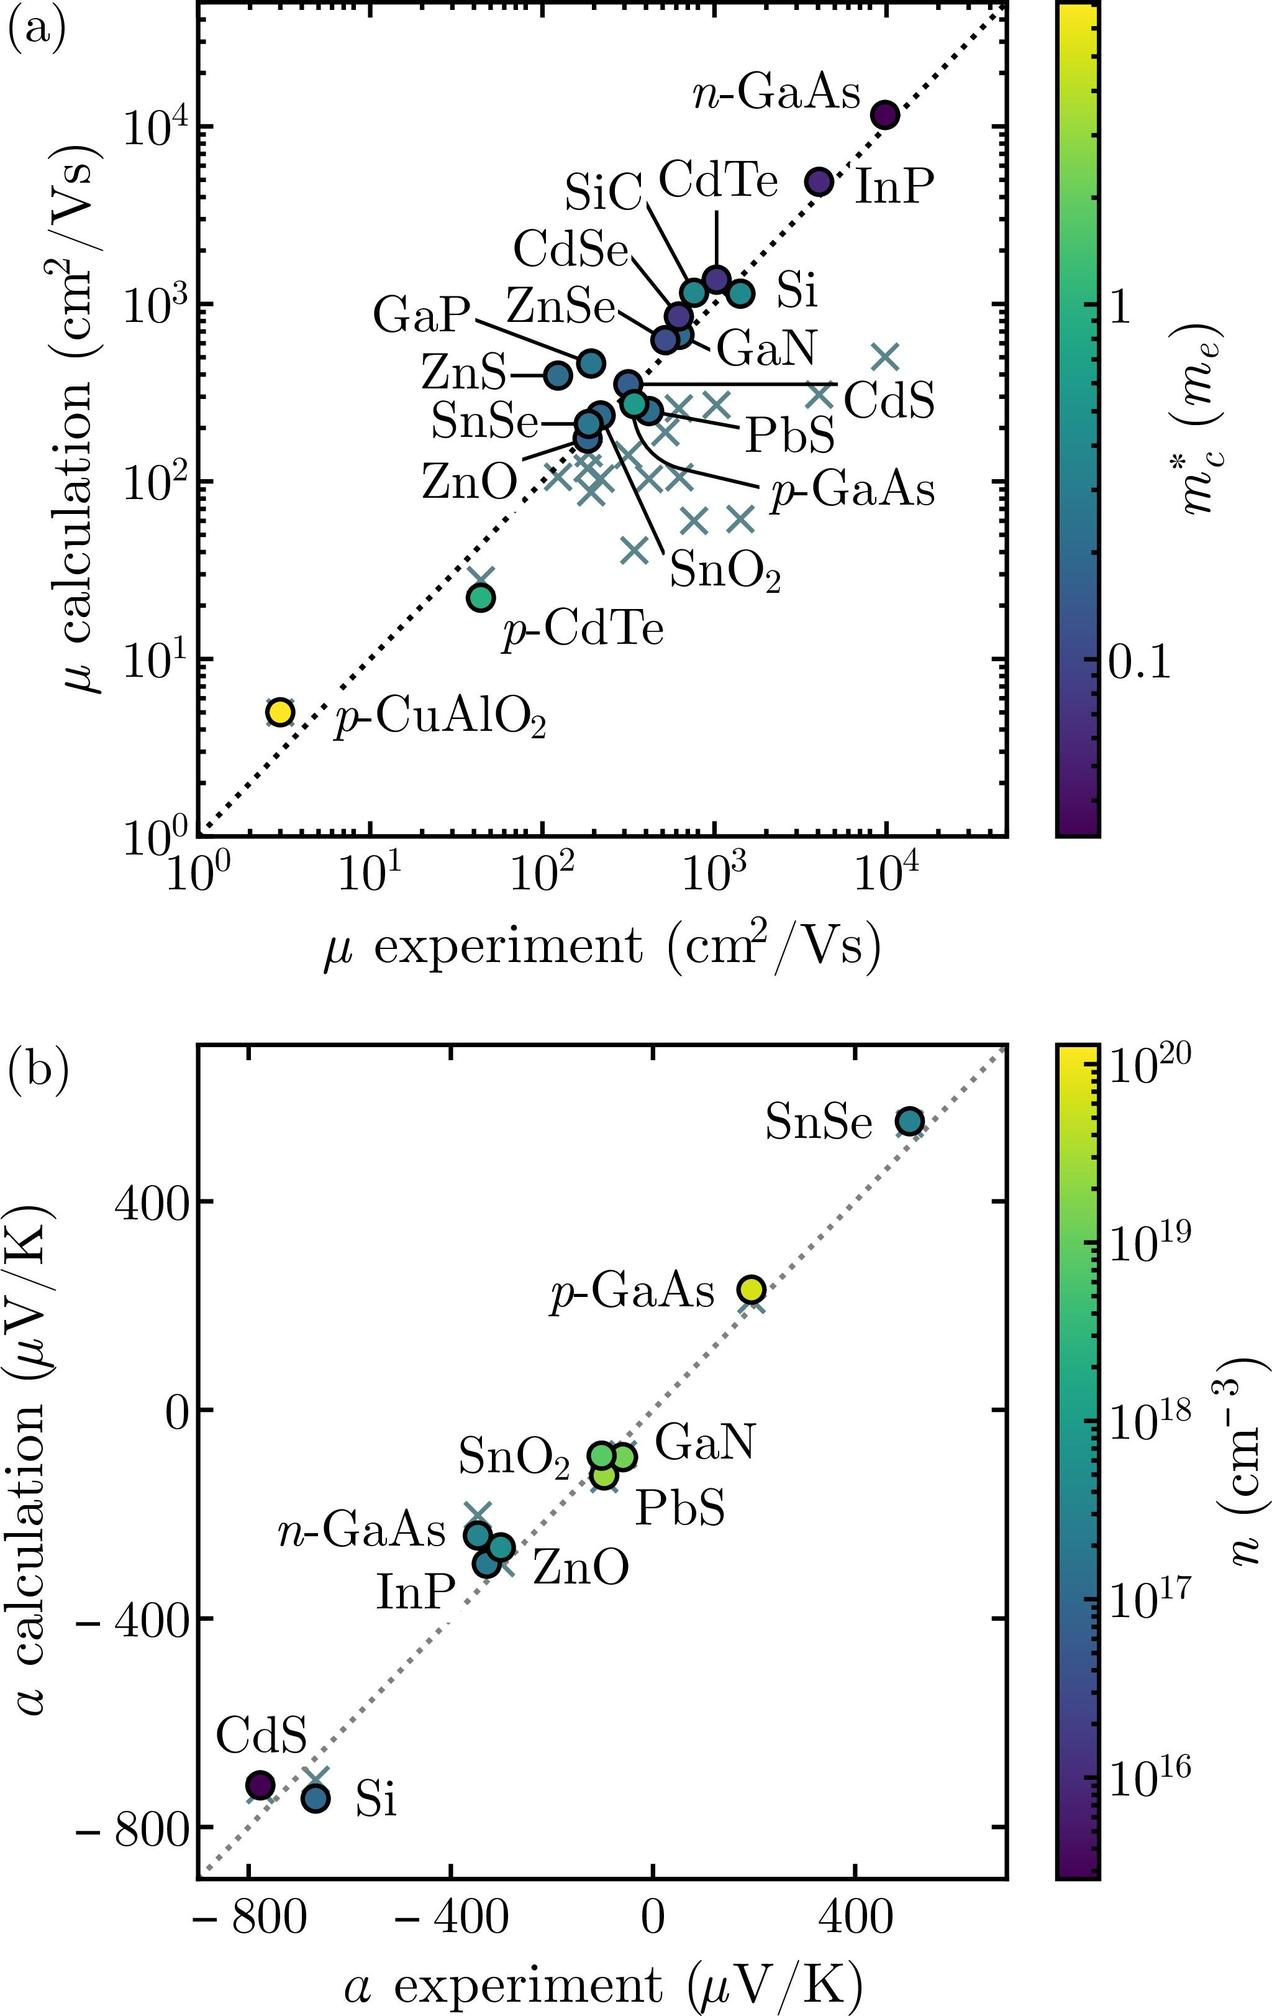Can you explain the significance of the color gradient in the plot? Certainly! The color gradient in the plot represents the carrier concentration (typically denoted by \( n \)) of the various semiconductor materials. This value is expressed in units of \( cm^{-3} \) and spans several orders of magnitude. The gradient ranges from purple, denoting a lower carrier concentration (\( 10^{16} \ cm^{-3} \)), to green, and then to yellow for the highest concentration depicted (\( 10^{20} \ cm^{-3} \)). This color-coding allows us to quickly visualize and compare the carrier concentrations of the materials alongside their Seebeck coefficients. 